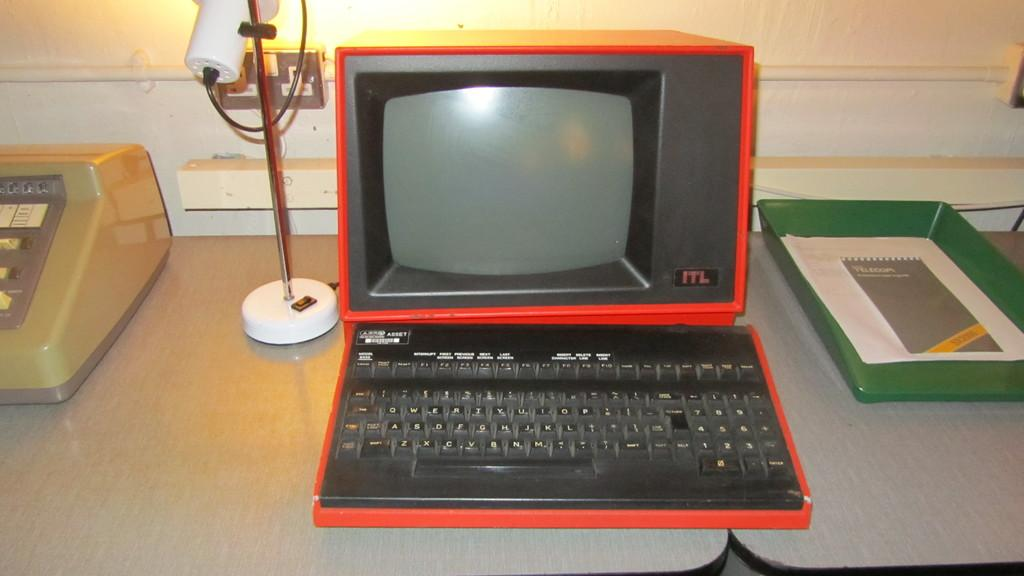<image>
Write a terse but informative summary of the picture. An older computer that is red from the maker ITL. 